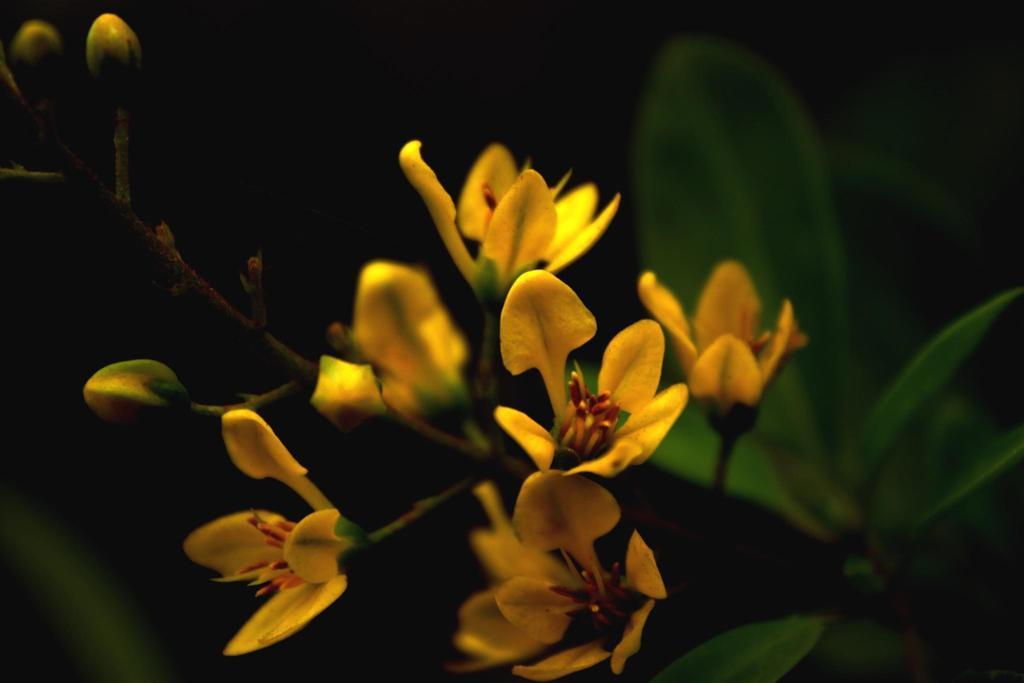Describe this image in one or two sentences. In the center of the image there is a plant with flowers. 